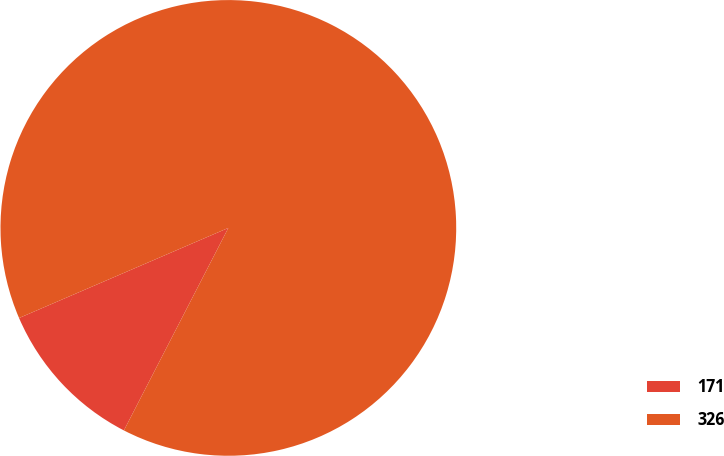Convert chart. <chart><loc_0><loc_0><loc_500><loc_500><pie_chart><fcel>171<fcel>326<nl><fcel>10.95%<fcel>89.05%<nl></chart> 